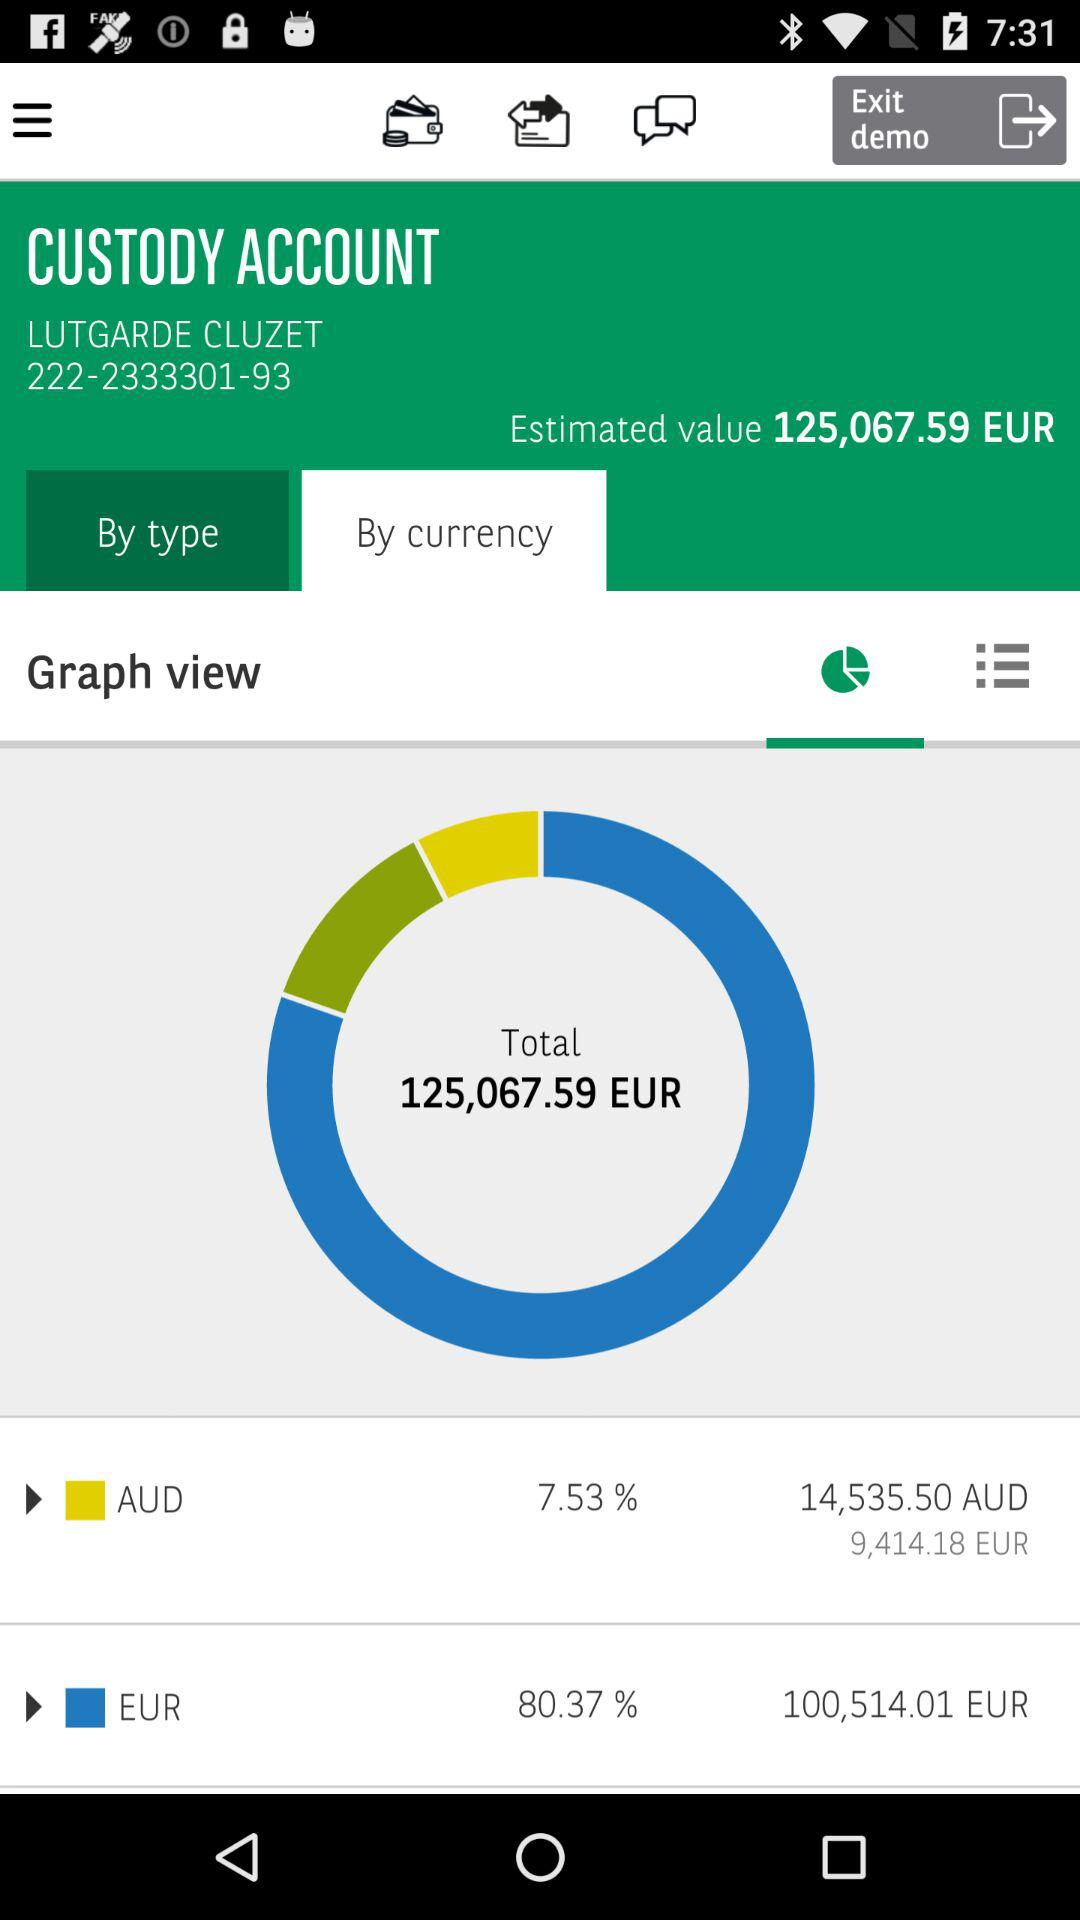What is the total value of all the assets in this custody account?
Answer the question using a single word or phrase. 125,067.59 EUR 